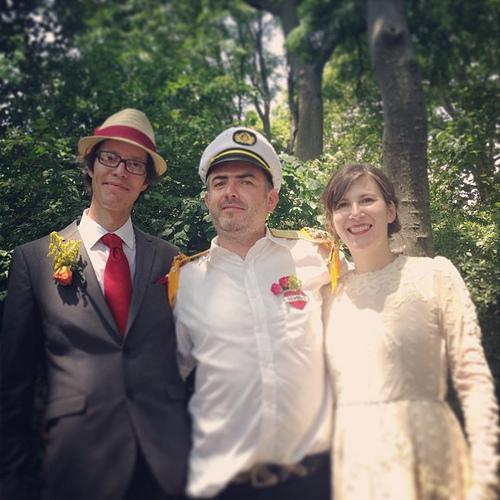Name the three main items of clothing the groom is wearing in the image. The groom is wearing a grey suit jacket, white shirt, and red tie. What elements of nature can be seen in the image? There are green tree leaves, brown tree bark, and a large gray tree branch in the image. Describe the appearance of the woman who is not the bride. The woman is smiling and wearing a beige dress. What is the collective appearance of the people in the image? Three people are standing side by side, including a smiling bride in a white lace dress, a groom in a grey suit with a red tie, and a man in a white cap. Identify the color and type of hat worn by one of the men in the image. A man is wearing a brown and red straw hat with a red band. What are the specific characteristics of the groom's suit in the image? The groom's suit is grey, worn with a red tie, and has a red flower on the lapel. Describe the main subjects and their mutual action in the image. Three people, including a bride and groom, are posing together with a man in a captain's hat for a photograph, all smiling and happy. What is the unique feature of the tie worn by one man in the image? The man's tie is red, worn under a white collar. What are the key features of the man in the captain's hat? The man is wearing a white captain's hat with a gold emblem, a partially untucked white shirt with epaulettes, and a heart on the pocket. What is the notable accessory on the bride in the image? The bride is wearing a long sleeve white lace dress. 